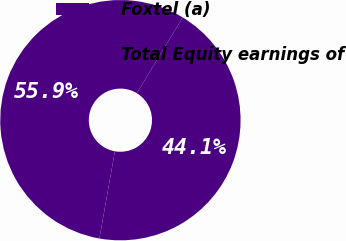Convert chart. <chart><loc_0><loc_0><loc_500><loc_500><pie_chart><fcel>Foxtel (a)<fcel>Total Equity earnings of<nl><fcel>55.88%<fcel>44.12%<nl></chart> 